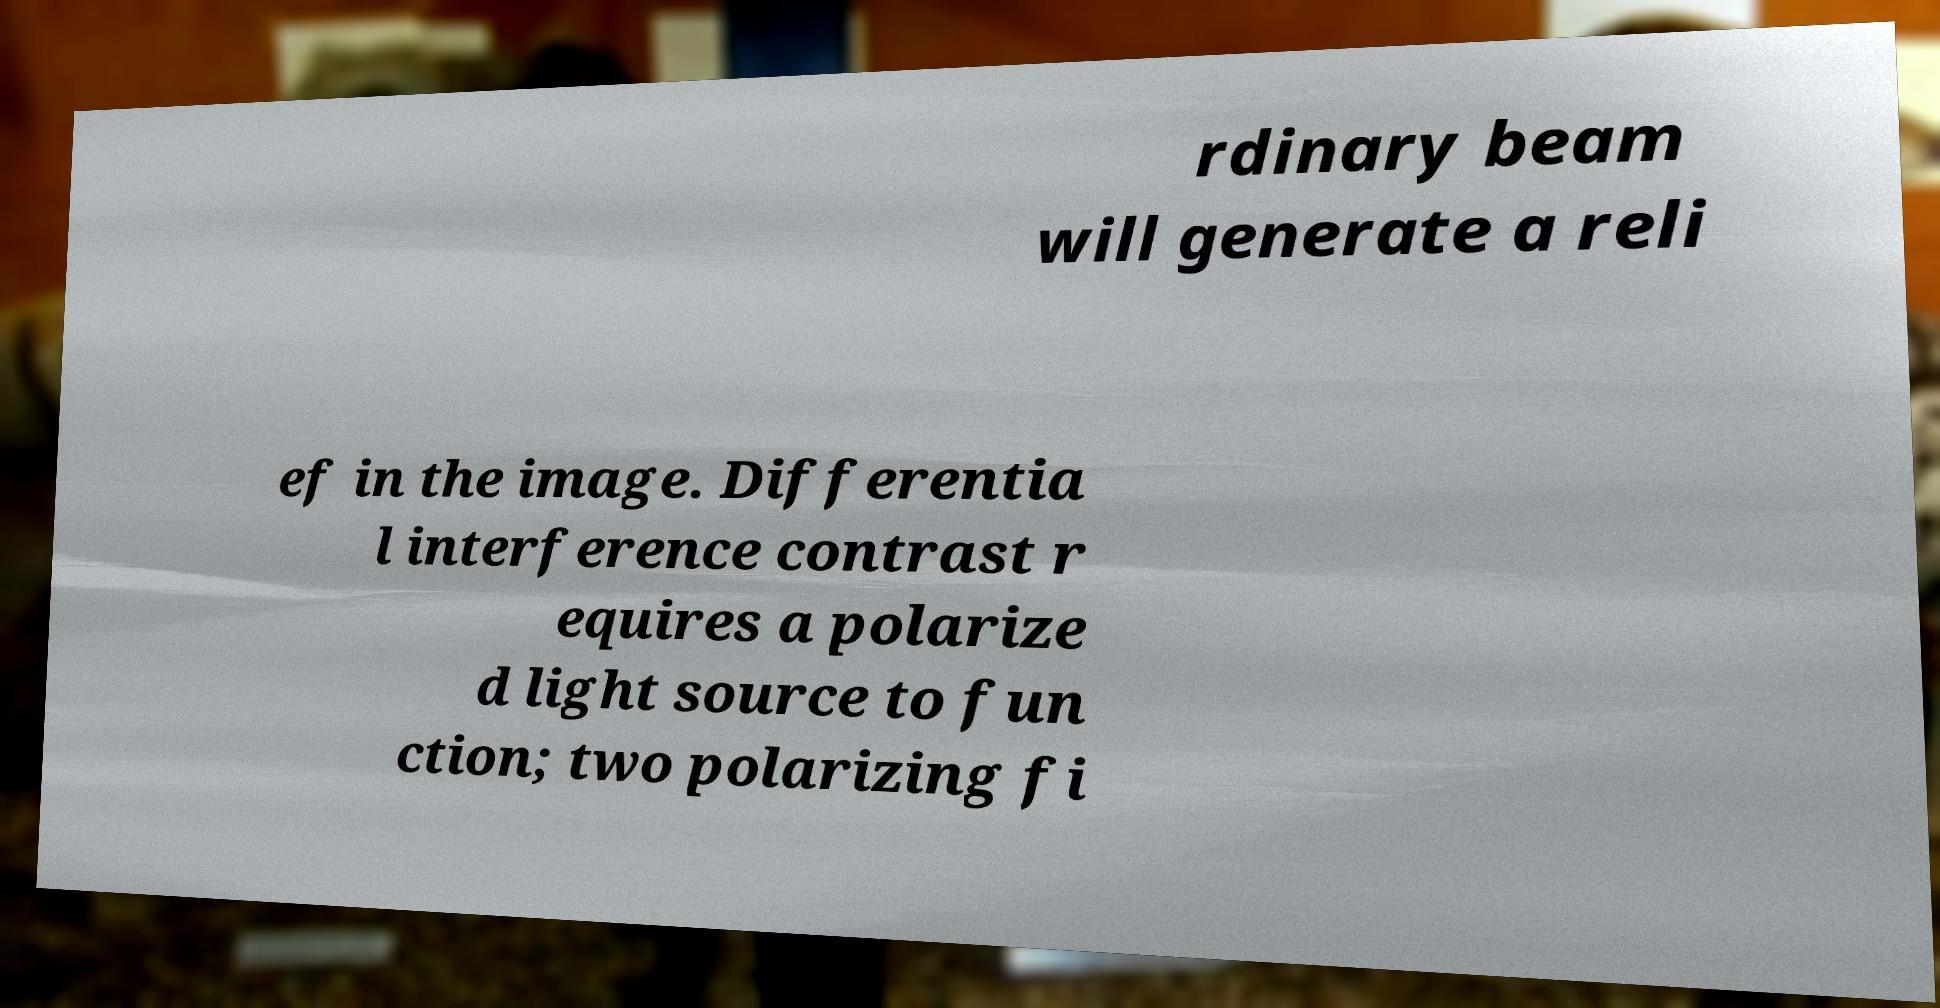Can you read and provide the text displayed in the image?This photo seems to have some interesting text. Can you extract and type it out for me? rdinary beam will generate a reli ef in the image. Differentia l interference contrast r equires a polarize d light source to fun ction; two polarizing fi 